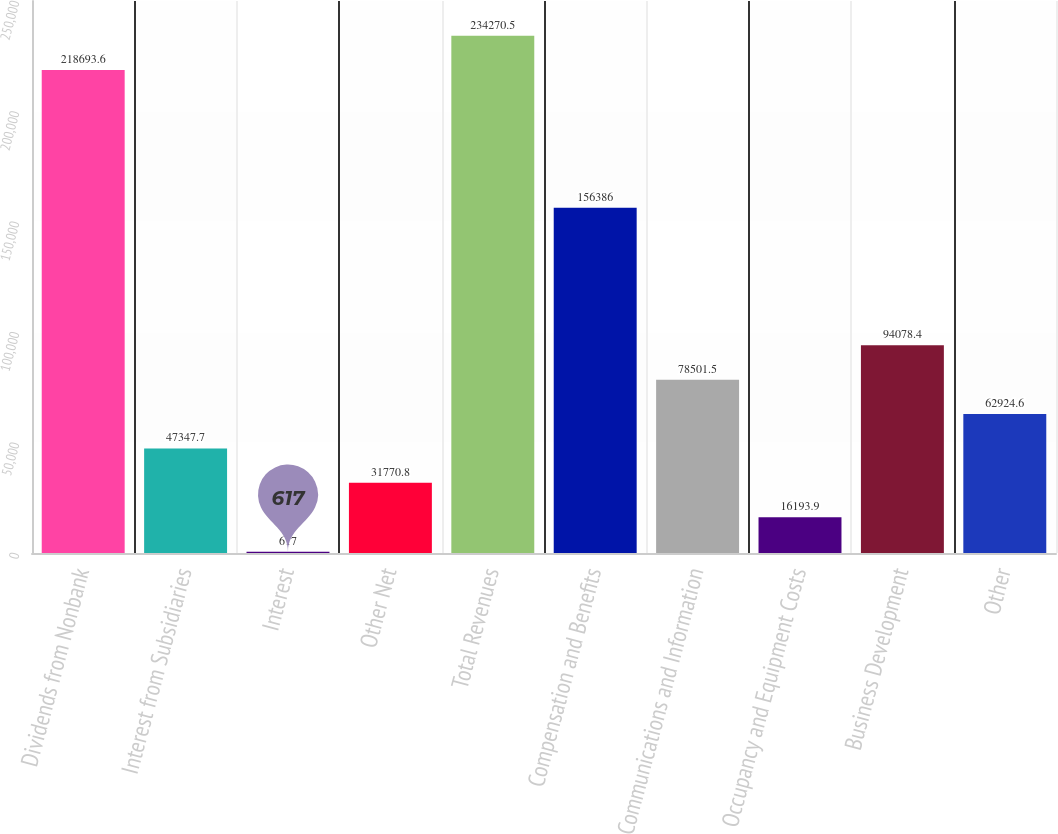Convert chart. <chart><loc_0><loc_0><loc_500><loc_500><bar_chart><fcel>Dividends from Nonbank<fcel>Interest from Subsidiaries<fcel>Interest<fcel>Other Net<fcel>Total Revenues<fcel>Compensation and Benefits<fcel>Communications and Information<fcel>Occupancy and Equipment Costs<fcel>Business Development<fcel>Other<nl><fcel>218694<fcel>47347.7<fcel>617<fcel>31770.8<fcel>234270<fcel>156386<fcel>78501.5<fcel>16193.9<fcel>94078.4<fcel>62924.6<nl></chart> 